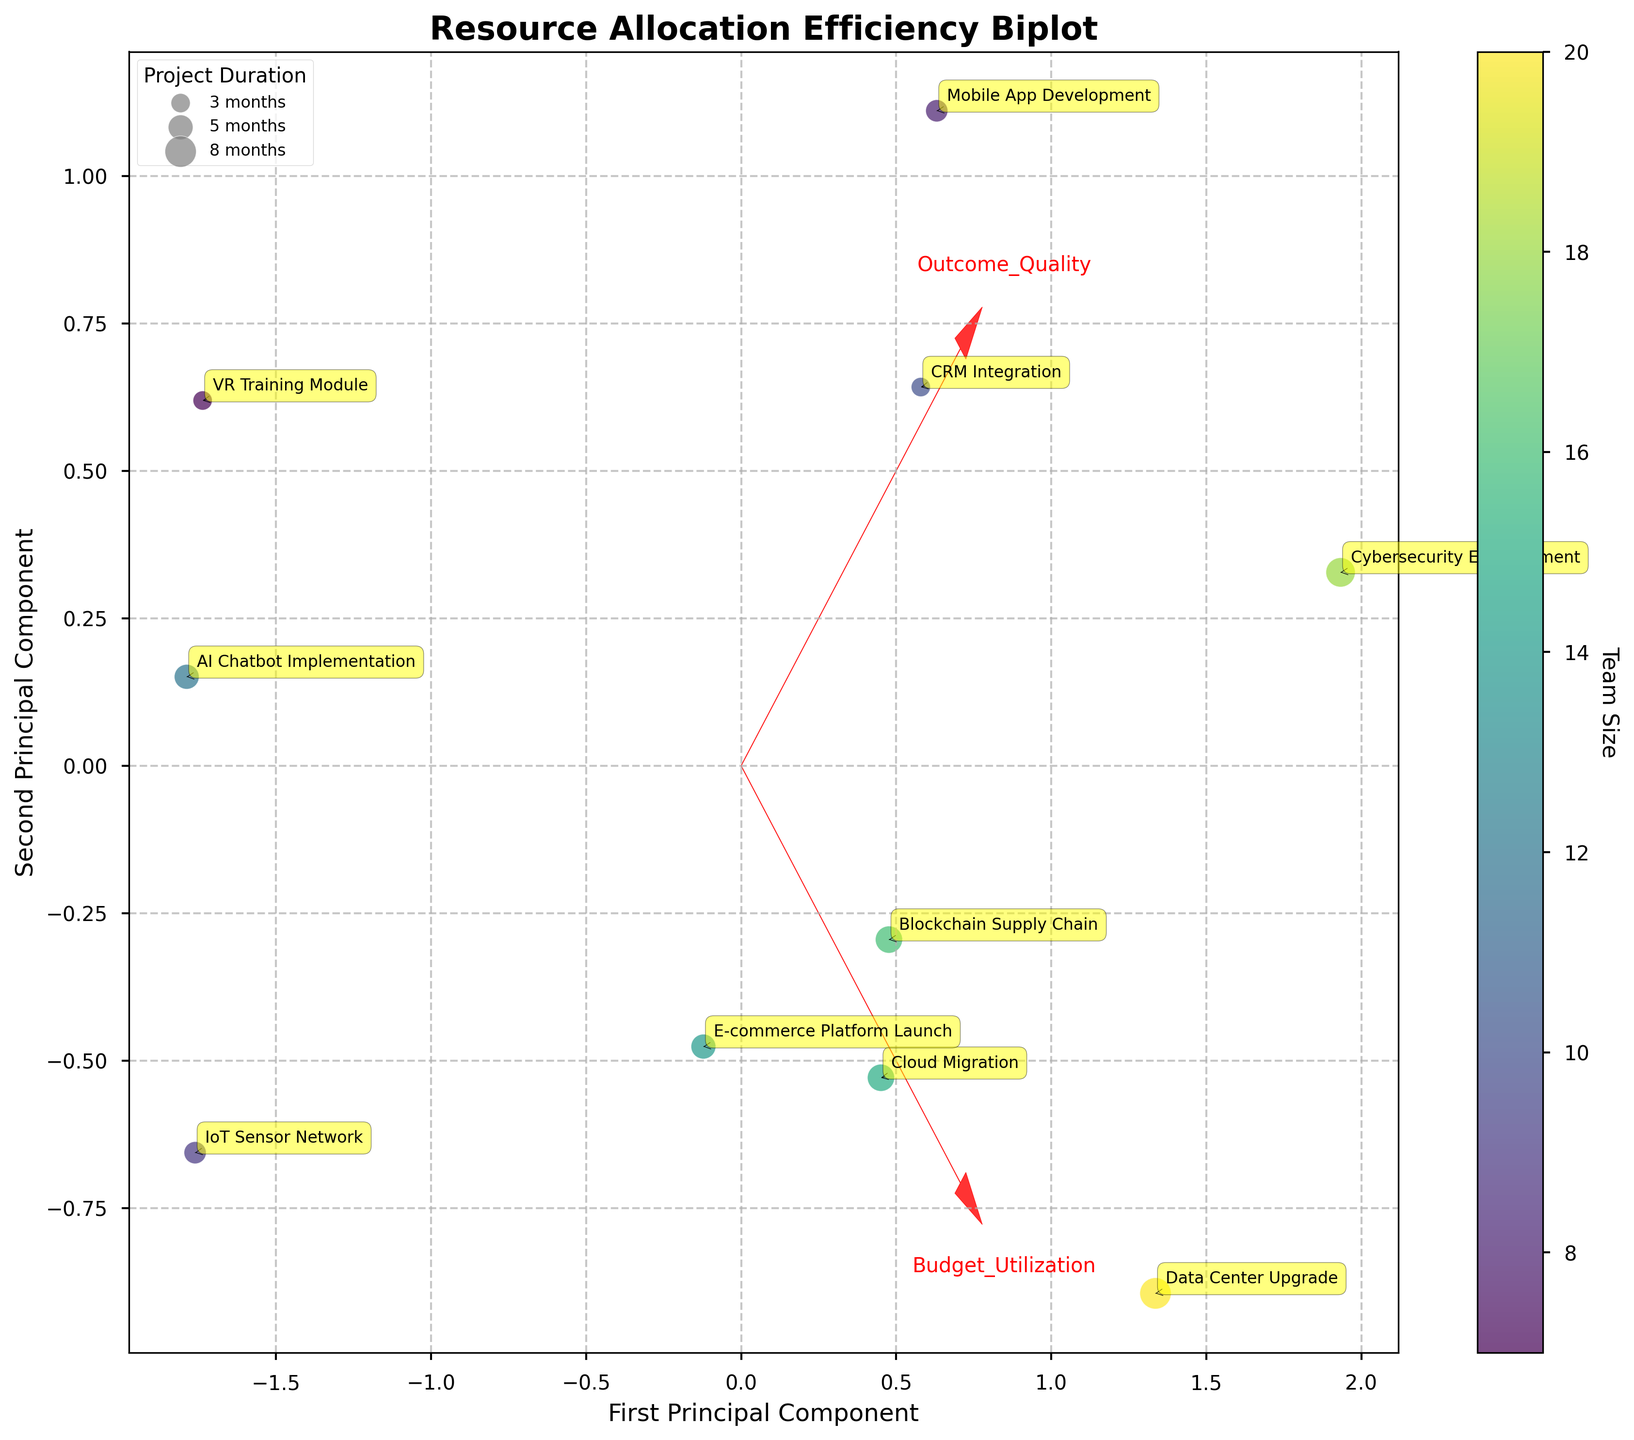What is the title of the figure? The title is generally located at the top of the figure and serves to succinctly describe what the figure is about.
Answer: Resource Allocation Efficiency Biplot What do the x and y axes represent? The x and y axes are usually labeled to help interpret the two dimensions of the data. According to the code provided, the x axis is labeled "First Principal Component" and the y axis is labeled "Second Principal Component".
Answer: First Principal Component, Second Principal Component How is the team size represented in the figure? The color of the points in the scatter plot represents the team size. Different shades in the 'viridis' colormap correspond to different team sizes, and there is a color bar provided to map these shades to specific team sizes.
Answer: Color of points Which project had the highest outcome quality? By looking at the annotated project points and correlating them with the outcome quality in the dataset, the project with the highest outcome quality is Cybersecurity Enhancement.
Answer: Cybersecurity Enhancement Which project is represented by the largest bubble in the plot? The size of the bubbles in the scatter plot represents the project duration in months. The largest bubble represents the Data Center Upgrade project, as it has a project duration of 8 months.
Answer: Data Center Upgrade How many projects are annotated in the plot? Each project is annotated in the plot, and we can count the annotations to find the number of projects.
Answer: 10 Which component (Budget Utilization or Outcome Quality) has a longer feature vector? The length of the feature vectors can be estimated by comparing the arrows. The Budget Utilization vector appears longer, indicating it has a stronger influence in differentiating the data along the first principal component.
Answer: Budget Utilization How many projects have a project duration of 5 months? By observing the plot and the legend for project duration, several bubbles correspond to the 5-month duration category size. Counting these bubbles on the plot, we find there are two projects: E-commerce Platform Launch and AI Chatbot Implementation.
Answer: 2 Is there any project with a team size of 12 represented in the plot, and if so, which project(s)? The color bar indicates team sizes, and we can correlate the colors with respective data points. By looking closer at the scatter plot, we find that AI Chatbot Implementation corresponds to a team size of 12.
Answer: AI Chatbot Implementation What can be said about the relationship between Budget Utilization and Outcome Quality? The vectors in the biplot for Budget Utilization and Outcome Quality both point in similar directions, indicating a positive correlation between these two features. Projects with higher budget utilization tend to have higher outcome quality.
Answer: Positive correlation 